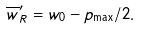<formula> <loc_0><loc_0><loc_500><loc_500>\overline { w } _ { R } ^ { \prime } = w _ { 0 } - p _ { \max } / 2 .</formula> 